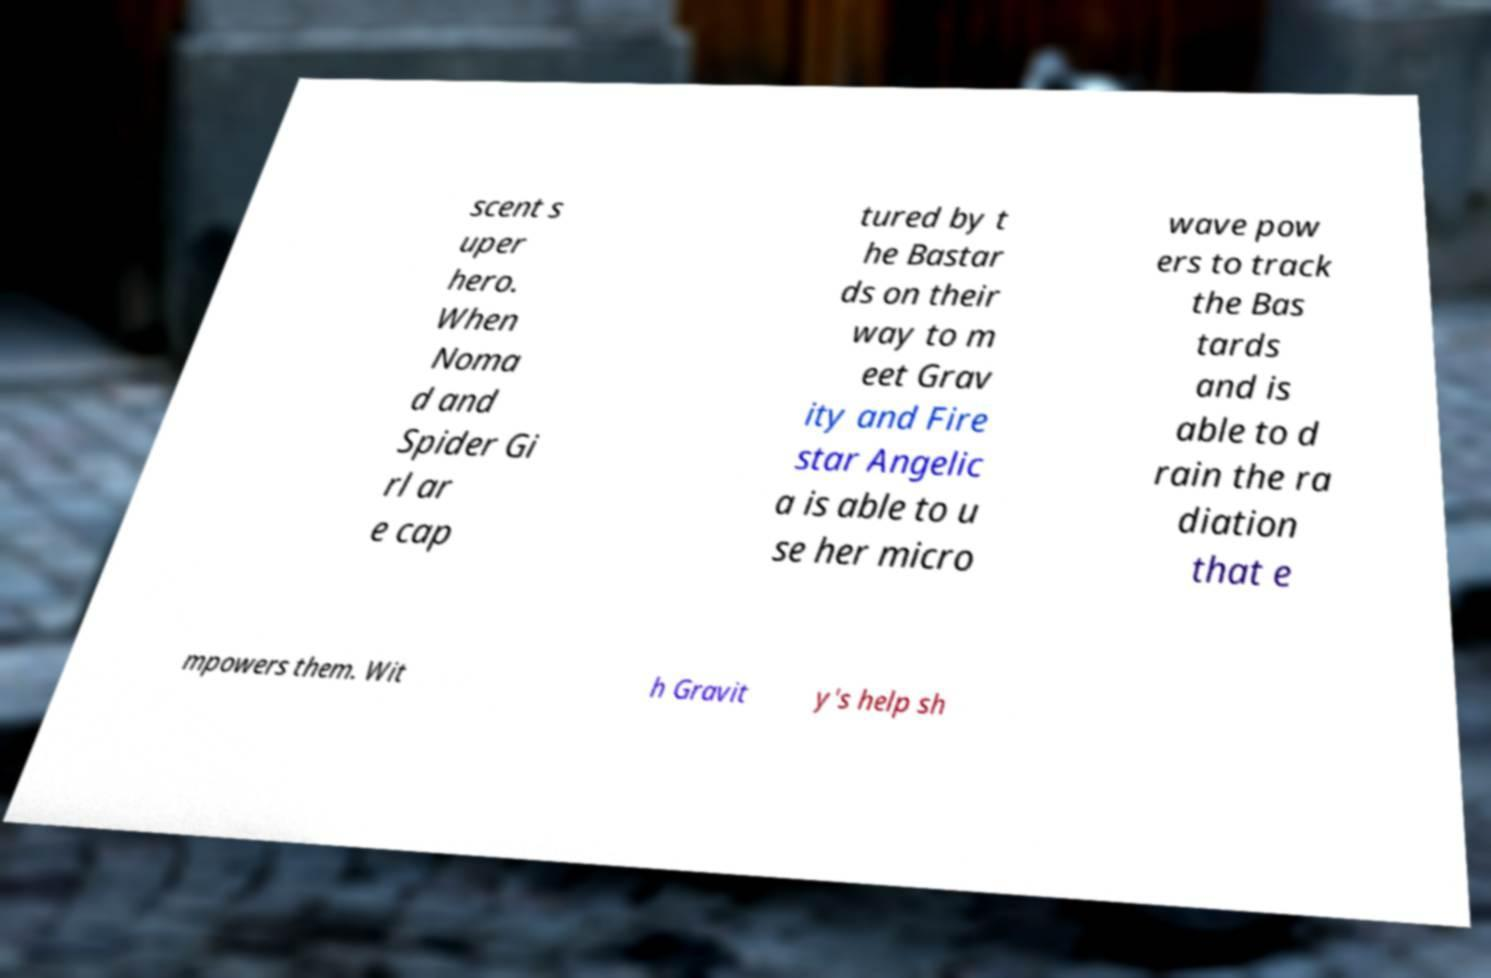For documentation purposes, I need the text within this image transcribed. Could you provide that? scent s uper hero. When Noma d and Spider Gi rl ar e cap tured by t he Bastar ds on their way to m eet Grav ity and Fire star Angelic a is able to u se her micro wave pow ers to track the Bas tards and is able to d rain the ra diation that e mpowers them. Wit h Gravit y's help sh 